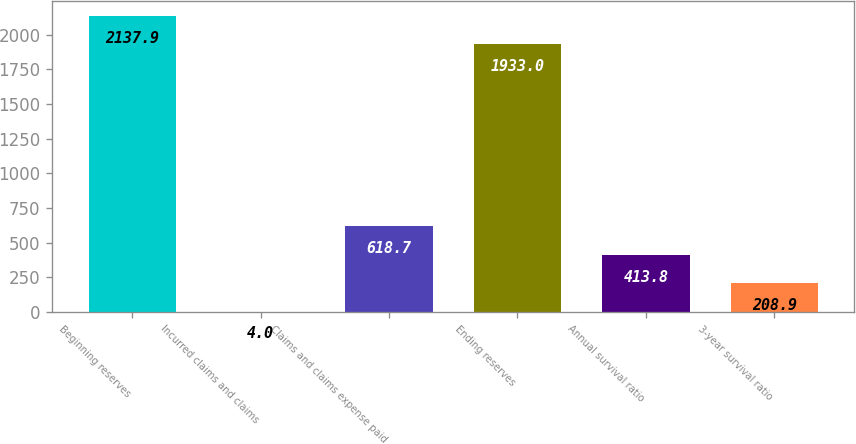<chart> <loc_0><loc_0><loc_500><loc_500><bar_chart><fcel>Beginning reserves<fcel>Incurred claims and claims<fcel>Claims and claims expense paid<fcel>Ending reserves<fcel>Annual survival ratio<fcel>3-year survival ratio<nl><fcel>2137.9<fcel>4<fcel>618.7<fcel>1933<fcel>413.8<fcel>208.9<nl></chart> 